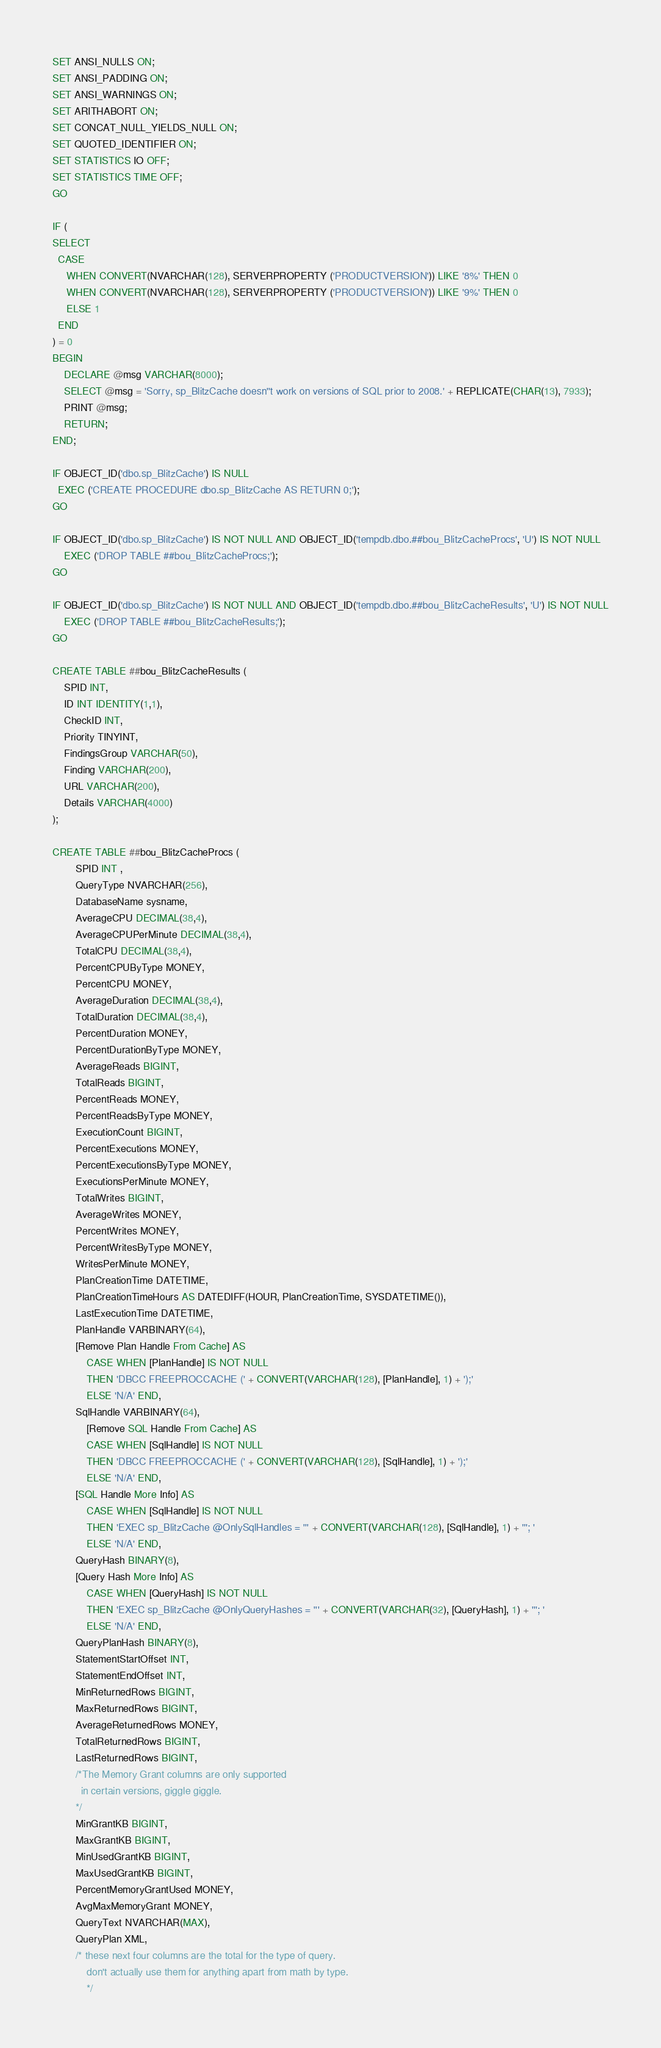<code> <loc_0><loc_0><loc_500><loc_500><_SQL_>SET ANSI_NULLS ON;
SET ANSI_PADDING ON;
SET ANSI_WARNINGS ON;
SET ARITHABORT ON;
SET CONCAT_NULL_YIELDS_NULL ON;
SET QUOTED_IDENTIFIER ON;
SET STATISTICS IO OFF;
SET STATISTICS TIME OFF;
GO

IF (
SELECT
  CASE 
     WHEN CONVERT(NVARCHAR(128), SERVERPROPERTY ('PRODUCTVERSION')) LIKE '8%' THEN 0
     WHEN CONVERT(NVARCHAR(128), SERVERPROPERTY ('PRODUCTVERSION')) LIKE '9%' THEN 0
	 ELSE 1
  END 
) = 0
BEGIN
	DECLARE @msg VARCHAR(8000); 
	SELECT @msg = 'Sorry, sp_BlitzCache doesn''t work on versions of SQL prior to 2008.' + REPLICATE(CHAR(13), 7933);
	PRINT @msg;
	RETURN;
END;

IF OBJECT_ID('dbo.sp_BlitzCache') IS NULL
  EXEC ('CREATE PROCEDURE dbo.sp_BlitzCache AS RETURN 0;');
GO

IF OBJECT_ID('dbo.sp_BlitzCache') IS NOT NULL AND OBJECT_ID('tempdb.dbo.##bou_BlitzCacheProcs', 'U') IS NOT NULL
    EXEC ('DROP TABLE ##bou_BlitzCacheProcs;');
GO

IF OBJECT_ID('dbo.sp_BlitzCache') IS NOT NULL AND OBJECT_ID('tempdb.dbo.##bou_BlitzCacheResults', 'U') IS NOT NULL
    EXEC ('DROP TABLE ##bou_BlitzCacheResults;');
GO

CREATE TABLE ##bou_BlitzCacheResults (
    SPID INT,
    ID INT IDENTITY(1,1),
    CheckID INT,
    Priority TINYINT,
    FindingsGroup VARCHAR(50),
    Finding VARCHAR(200),
    URL VARCHAR(200),
    Details VARCHAR(4000) 
);

CREATE TABLE ##bou_BlitzCacheProcs (
        SPID INT ,
        QueryType NVARCHAR(256),
        DatabaseName sysname,
        AverageCPU DECIMAL(38,4),
        AverageCPUPerMinute DECIMAL(38,4),
        TotalCPU DECIMAL(38,4),
        PercentCPUByType MONEY,
        PercentCPU MONEY,
        AverageDuration DECIMAL(38,4),
        TotalDuration DECIMAL(38,4),
        PercentDuration MONEY,
        PercentDurationByType MONEY,
        AverageReads BIGINT,
        TotalReads BIGINT,
        PercentReads MONEY,
        PercentReadsByType MONEY,
        ExecutionCount BIGINT,
        PercentExecutions MONEY,
        PercentExecutionsByType MONEY,
        ExecutionsPerMinute MONEY,
        TotalWrites BIGINT,
        AverageWrites MONEY,
        PercentWrites MONEY,
        PercentWritesByType MONEY,
        WritesPerMinute MONEY,
        PlanCreationTime DATETIME,
		PlanCreationTimeHours AS DATEDIFF(HOUR, PlanCreationTime, SYSDATETIME()),
        LastExecutionTime DATETIME,
        PlanHandle VARBINARY(64),
		[Remove Plan Handle From Cache] AS 
			CASE WHEN [PlanHandle] IS NOT NULL 
			THEN 'DBCC FREEPROCCACHE (' + CONVERT(VARCHAR(128), [PlanHandle], 1) + ');'
			ELSE 'N/A' END,
		SqlHandle VARBINARY(64),
			[Remove SQL Handle From Cache] AS 
			CASE WHEN [SqlHandle] IS NOT NULL 
			THEN 'DBCC FREEPROCCACHE (' + CONVERT(VARCHAR(128), [SqlHandle], 1) + ');'
			ELSE 'N/A' END,
		[SQL Handle More Info] AS 
			CASE WHEN [SqlHandle] IS NOT NULL 
			THEN 'EXEC sp_BlitzCache @OnlySqlHandles = ''' + CONVERT(VARCHAR(128), [SqlHandle], 1) + '''; '
			ELSE 'N/A' END,
		QueryHash BINARY(8),
		[Query Hash More Info] AS 
			CASE WHEN [QueryHash] IS NOT NULL 
			THEN 'EXEC sp_BlitzCache @OnlyQueryHashes = ''' + CONVERT(VARCHAR(32), [QueryHash], 1) + '''; '
			ELSE 'N/A' END,
        QueryPlanHash BINARY(8),
        StatementStartOffset INT,
        StatementEndOffset INT,
        MinReturnedRows BIGINT,
        MaxReturnedRows BIGINT,
        AverageReturnedRows MONEY,
        TotalReturnedRows BIGINT,
        LastReturnedRows BIGINT,
		/*The Memory Grant columns are only supported 
		  in certain versions, giggle giggle.
		*/
		MinGrantKB BIGINT,
		MaxGrantKB BIGINT,
		MinUsedGrantKB BIGINT, 
		MaxUsedGrantKB BIGINT,
		PercentMemoryGrantUsed MONEY,
		AvgMaxMemoryGrant MONEY,
        QueryText NVARCHAR(MAX),
        QueryPlan XML,
        /* these next four columns are the total for the type of query.
            don't actually use them for anything apart from math by type.
            */</code> 